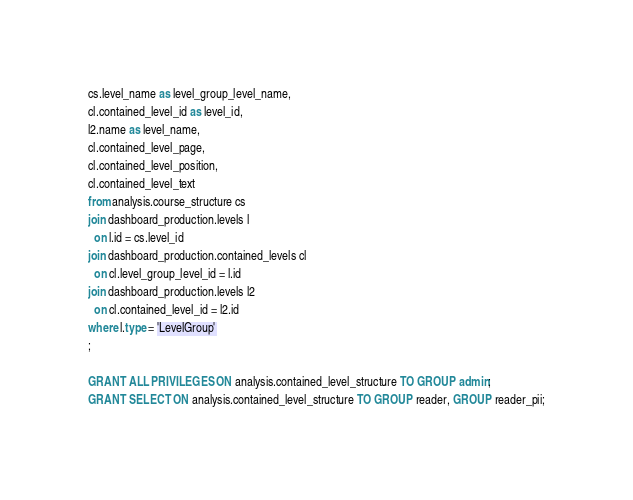Convert code to text. <code><loc_0><loc_0><loc_500><loc_500><_SQL_>cs.level_name as level_group_level_name,
cl.contained_level_id as level_id,
l2.name as level_name, 
cl.contained_level_page,
cl.contained_level_position,
cl.contained_level_text
from analysis.course_structure cs
join dashboard_production.levels l
  on l.id = cs.level_id 
join dashboard_production.contained_levels cl
  on cl.level_group_level_id = l.id 
join dashboard_production.levels l2
  on cl.contained_level_id = l2.id
where l.type = 'LevelGroup'
;

GRANT ALL PRIVILEGES ON analysis.contained_level_structure TO GROUP admin;
GRANT SELECT ON analysis.contained_level_structure TO GROUP reader, GROUP reader_pii;
</code> 